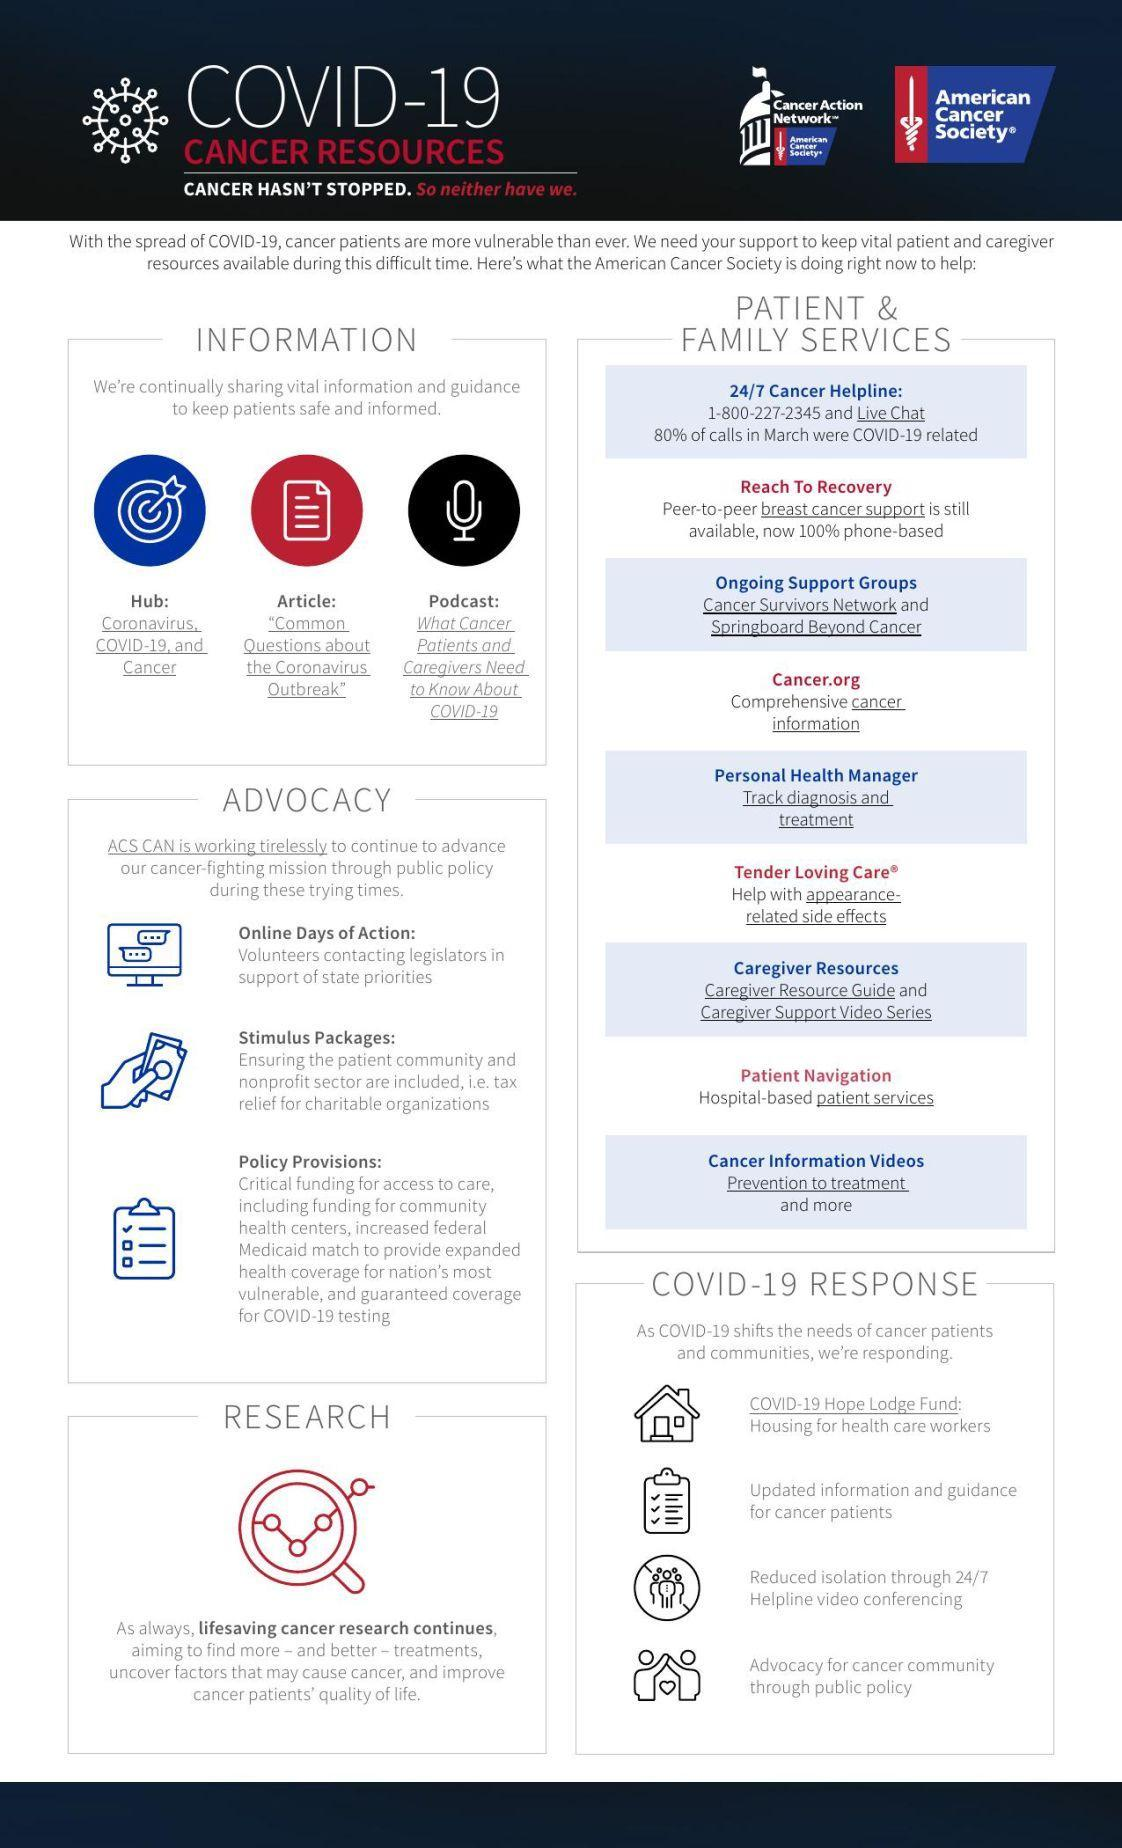How many points are under the heading Advocacy?
Answer the question with a short phrase. 3 How many points are under the heading Patient & Family Services? 9 